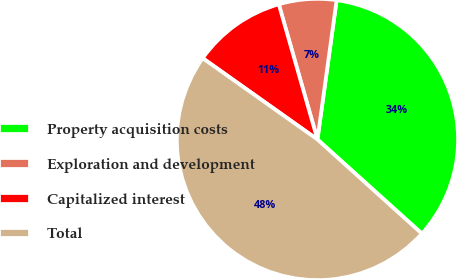<chart> <loc_0><loc_0><loc_500><loc_500><pie_chart><fcel>Property acquisition costs<fcel>Exploration and development<fcel>Capitalized interest<fcel>Total<nl><fcel>34.5%<fcel>6.61%<fcel>10.76%<fcel>48.13%<nl></chart> 